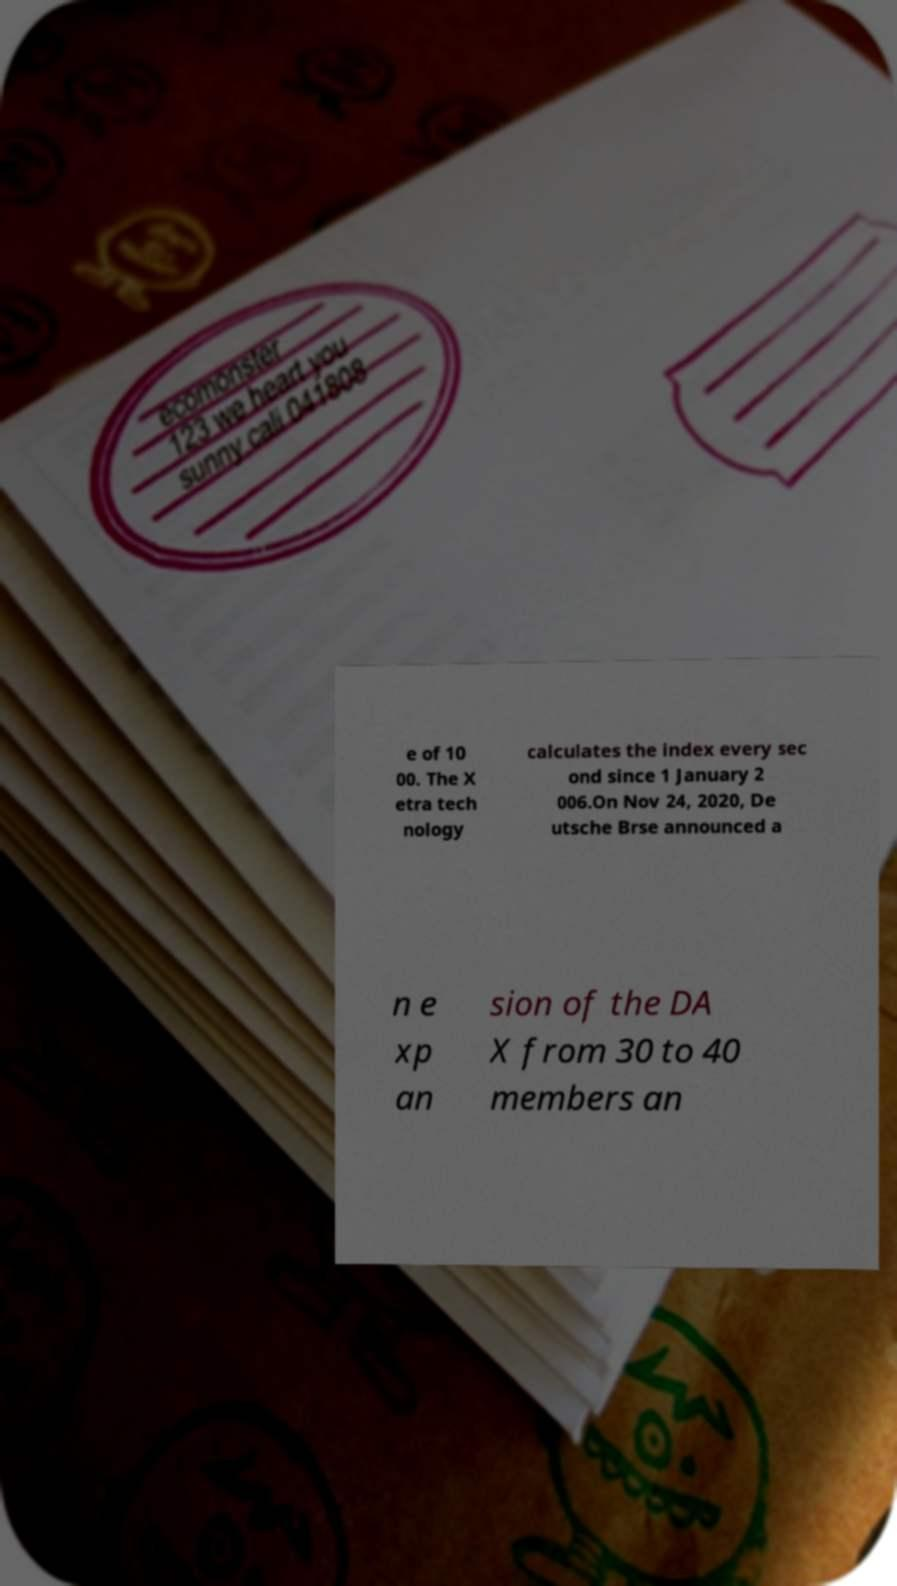For documentation purposes, I need the text within this image transcribed. Could you provide that? e of 10 00. The X etra tech nology calculates the index every sec ond since 1 January 2 006.On Nov 24, 2020, De utsche Brse announced a n e xp an sion of the DA X from 30 to 40 members an 